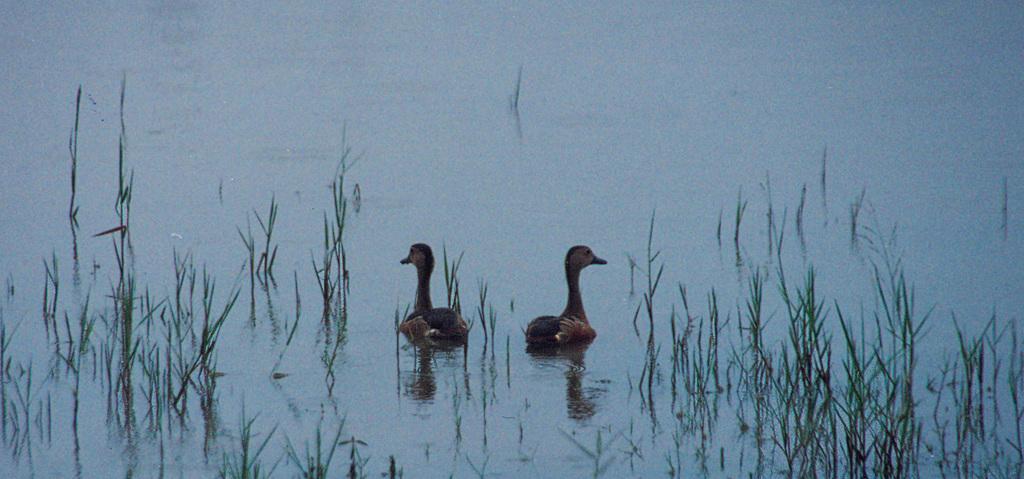Please provide a concise description of this image. In this picture we can see two small ducks in the lake water. In the front bottom side we can see some green grass. 